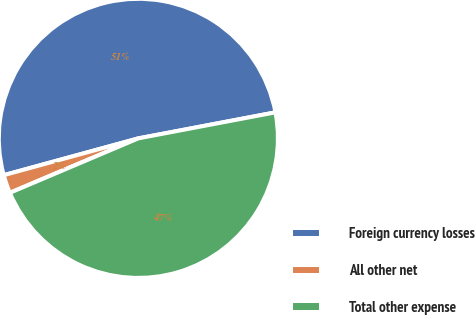Convert chart. <chart><loc_0><loc_0><loc_500><loc_500><pie_chart><fcel>Foreign currency losses<fcel>All other net<fcel>Total other expense<nl><fcel>51.26%<fcel>2.13%<fcel>46.6%<nl></chart> 